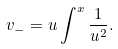Convert formula to latex. <formula><loc_0><loc_0><loc_500><loc_500>v _ { - } = u \int ^ { x } { \frac { 1 } { u ^ { 2 } } } .</formula> 